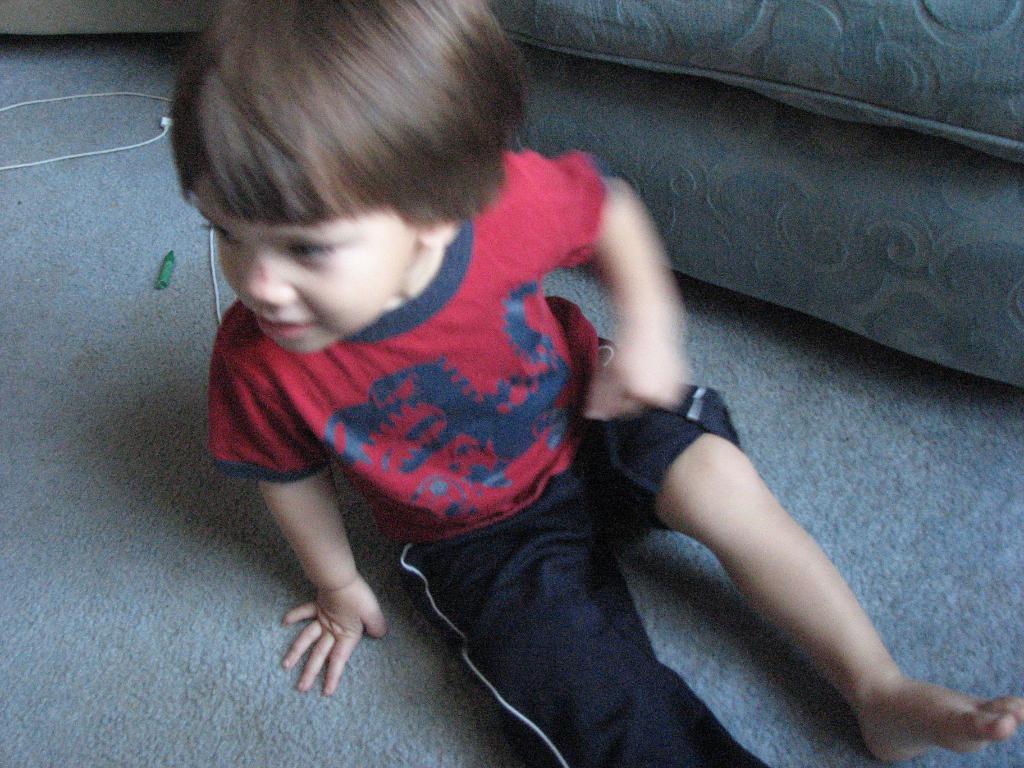In one or two sentences, can you explain what this image depicts? Here in this picture we can see a child sitting on the floor and smiling and beside him we can see a couch present. 